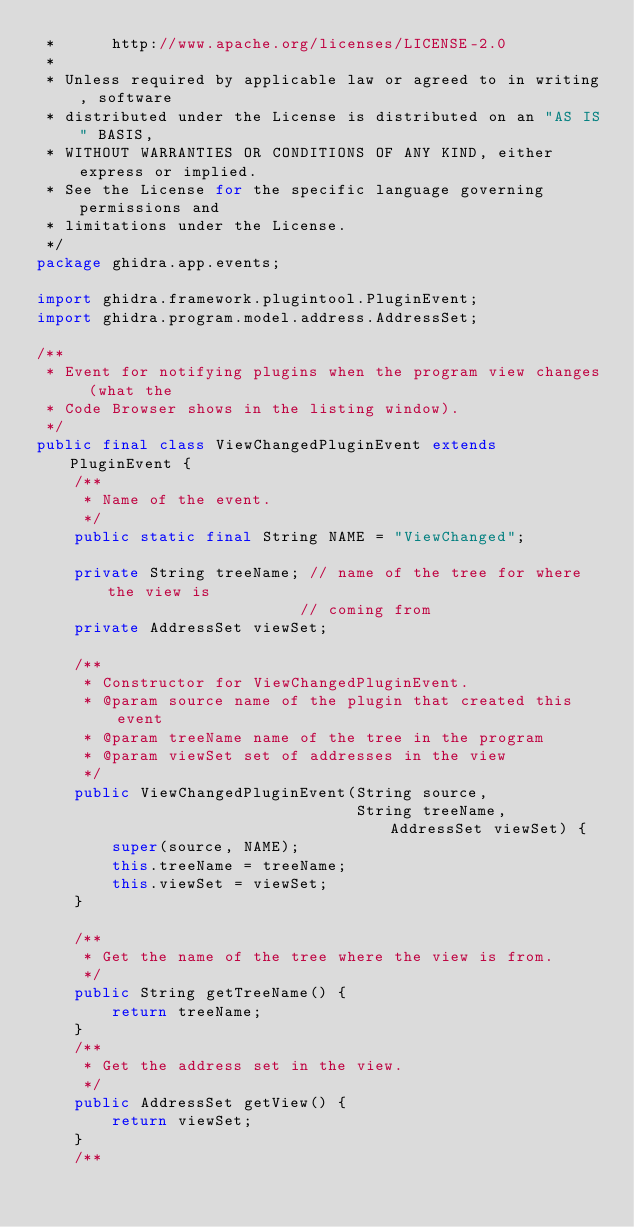<code> <loc_0><loc_0><loc_500><loc_500><_Java_> *      http://www.apache.org/licenses/LICENSE-2.0
 * 
 * Unless required by applicable law or agreed to in writing, software
 * distributed under the License is distributed on an "AS IS" BASIS,
 * WITHOUT WARRANTIES OR CONDITIONS OF ANY KIND, either express or implied.
 * See the License for the specific language governing permissions and
 * limitations under the License.
 */
package ghidra.app.events;

import ghidra.framework.plugintool.PluginEvent;
import ghidra.program.model.address.AddressSet;

/**
 * Event for notifying plugins when the program view changes (what the
 * Code Browser shows in the listing window).
 */
public final class ViewChangedPluginEvent extends PluginEvent {
	/**
	 * Name of the event.
	 */
	public static final String NAME = "ViewChanged";
	
	private String treeName; // name of the tree for where the view is
							// coming from
	private AddressSet viewSet;
	
	/**
	 * Constructor for ViewChangedPluginEvent.
	 * @param source name of the plugin that created this event
	 * @param treeName name of the tree in the program
	 * @param viewSet set of addresses in the view
	 */
	public ViewChangedPluginEvent(String source, 
								  String treeName, AddressSet viewSet) {
		super(source, NAME);
		this.treeName = treeName;
		this.viewSet = viewSet;
	}

	/**
	 * Get the name of the tree where the view is from.
	 */
	public String getTreeName() {
		return treeName;
	}
	/**
	 * Get the address set in the view.
	 */
	public AddressSet getView() {
		return viewSet;
	}
	/**</code> 